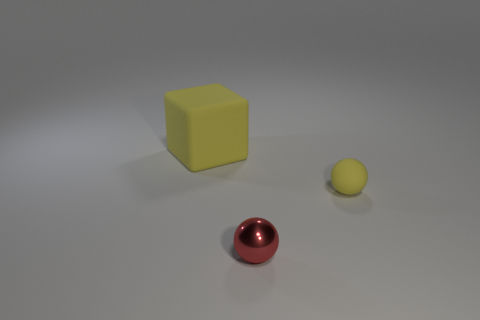Do the red metallic sphere and the yellow matte ball have the same size?
Provide a succinct answer. Yes. How many objects are either objects behind the yellow sphere or tiny balls?
Make the answer very short. 3. The yellow object that is to the right of the big matte block left of the tiny matte ball is what shape?
Offer a very short reply. Sphere. There is a yellow matte sphere; is it the same size as the ball that is in front of the tiny yellow ball?
Your response must be concise. Yes. What is the material of the tiny object that is to the left of the tiny yellow ball?
Provide a short and direct response. Metal. What number of things are on the right side of the small red metallic ball and on the left side of the yellow sphere?
Make the answer very short. 0. There is a red thing that is the same size as the yellow matte ball; what material is it?
Your answer should be very brief. Metal. There is a rubber object in front of the large matte cube; is it the same size as the rubber object left of the red thing?
Your answer should be compact. No. There is a tiny yellow rubber sphere; are there any small yellow things in front of it?
Keep it short and to the point. No. There is a sphere to the left of the yellow object that is to the right of the tiny shiny object; what is its color?
Provide a succinct answer. Red. 